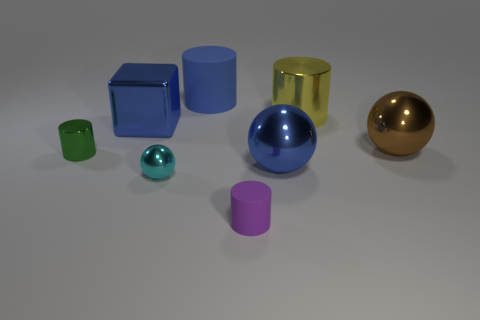If we imagine these objects are containers, which one could hold the most volume? Assuming all the objects are hollow, the large yellow cylinder would likely hold the most volume because of its height and cylindrical shape. 